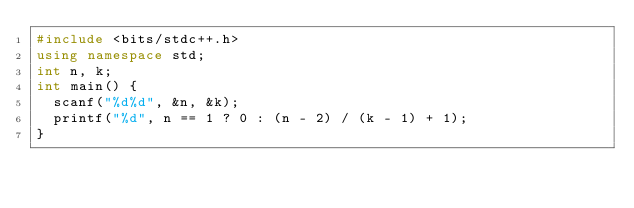Convert code to text. <code><loc_0><loc_0><loc_500><loc_500><_C++_>#include <bits/stdc++.h>
using namespace std;
int n, k;
int main() {
	scanf("%d%d", &n, &k);
	printf("%d", n == 1 ? 0 : (n - 2) / (k - 1) + 1);
}
</code> 